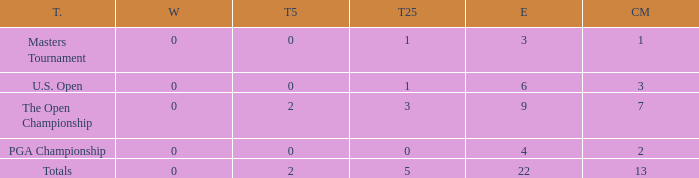What is the fewest wins for Thomas in events he had entered exactly 9 times? 0.0. 